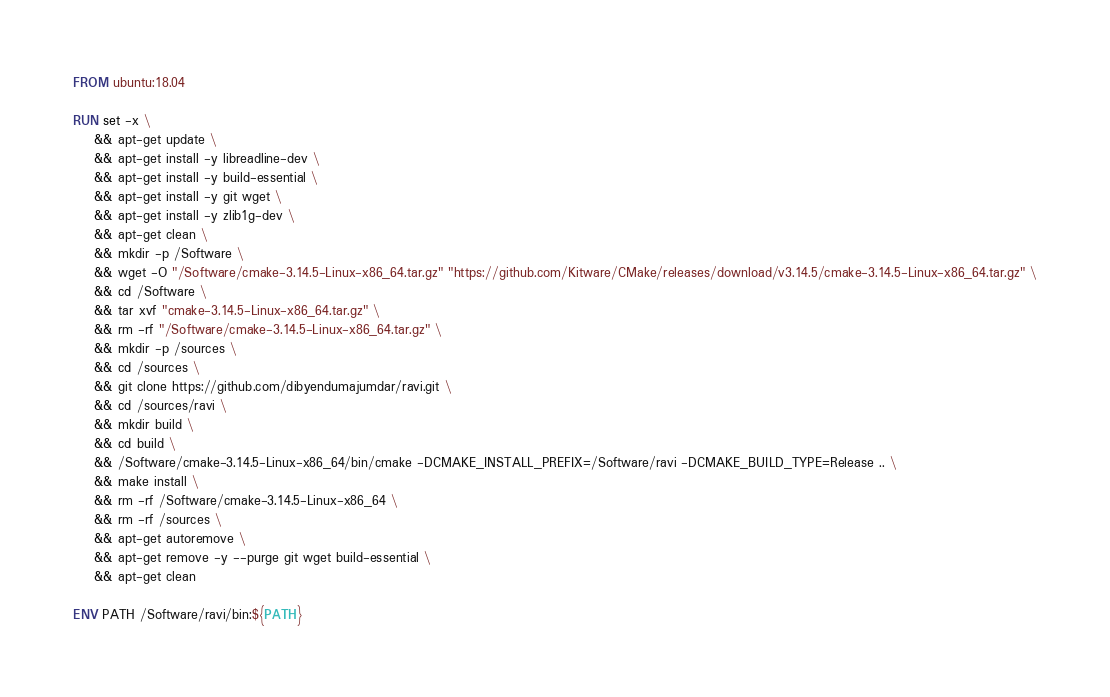<code> <loc_0><loc_0><loc_500><loc_500><_Dockerfile_>FROM ubuntu:18.04

RUN set -x \
    && apt-get update \
    && apt-get install -y libreadline-dev \
    && apt-get install -y build-essential \
    && apt-get install -y git wget \
    && apt-get install -y zlib1g-dev \
    && apt-get clean \
    && mkdir -p /Software \
    && wget -O "/Software/cmake-3.14.5-Linux-x86_64.tar.gz" "https://github.com/Kitware/CMake/releases/download/v3.14.5/cmake-3.14.5-Linux-x86_64.tar.gz" \
    && cd /Software \
    && tar xvf "cmake-3.14.5-Linux-x86_64.tar.gz" \
    && rm -rf "/Software/cmake-3.14.5-Linux-x86_64.tar.gz" \
    && mkdir -p /sources \
    && cd /sources \
    && git clone https://github.com/dibyendumajumdar/ravi.git \
    && cd /sources/ravi \
    && mkdir build \
    && cd build \
    && /Software/cmake-3.14.5-Linux-x86_64/bin/cmake -DCMAKE_INSTALL_PREFIX=/Software/ravi -DCMAKE_BUILD_TYPE=Release .. \
    && make install \
    && rm -rf /Software/cmake-3.14.5-Linux-x86_64 \
    && rm -rf /sources \
    && apt-get autoremove \
    && apt-get remove -y --purge git wget build-essential \
    && apt-get clean

ENV PATH /Software/ravi/bin:${PATH}

</code> 